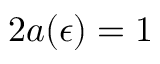Convert formula to latex. <formula><loc_0><loc_0><loc_500><loc_500>2 a ( \epsilon ) = 1</formula> 